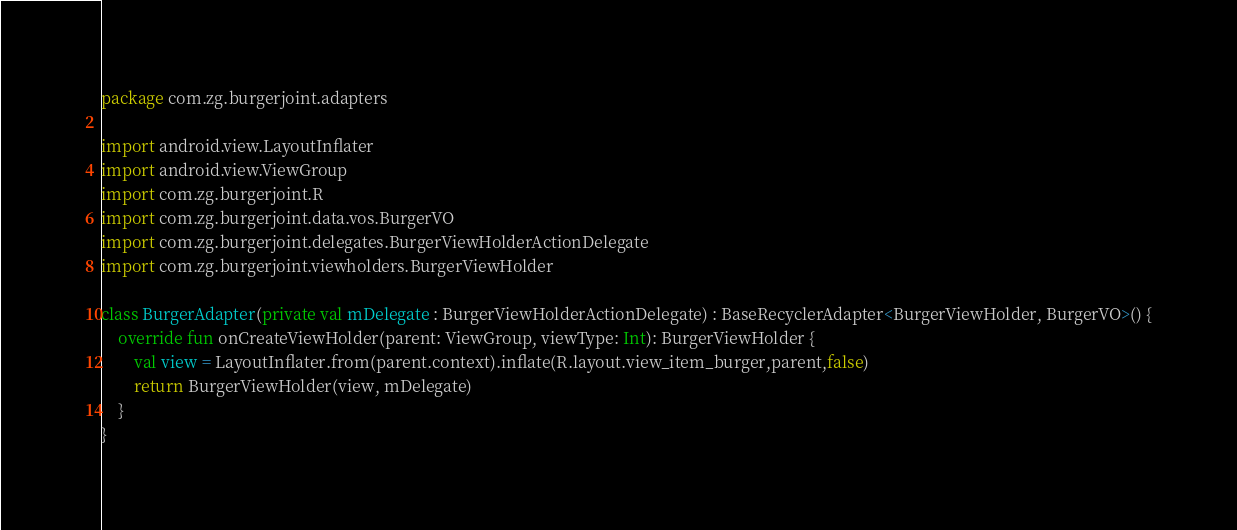<code> <loc_0><loc_0><loc_500><loc_500><_Kotlin_>package com.zg.burgerjoint.adapters

import android.view.LayoutInflater
import android.view.ViewGroup
import com.zg.burgerjoint.R
import com.zg.burgerjoint.data.vos.BurgerVO
import com.zg.burgerjoint.delegates.BurgerViewHolderActionDelegate
import com.zg.burgerjoint.viewholders.BurgerViewHolder

class BurgerAdapter(private val mDelegate : BurgerViewHolderActionDelegate) : BaseRecyclerAdapter<BurgerViewHolder, BurgerVO>() {
    override fun onCreateViewHolder(parent: ViewGroup, viewType: Int): BurgerViewHolder {
        val view = LayoutInflater.from(parent.context).inflate(R.layout.view_item_burger,parent,false)
        return BurgerViewHolder(view, mDelegate)
    }
}</code> 